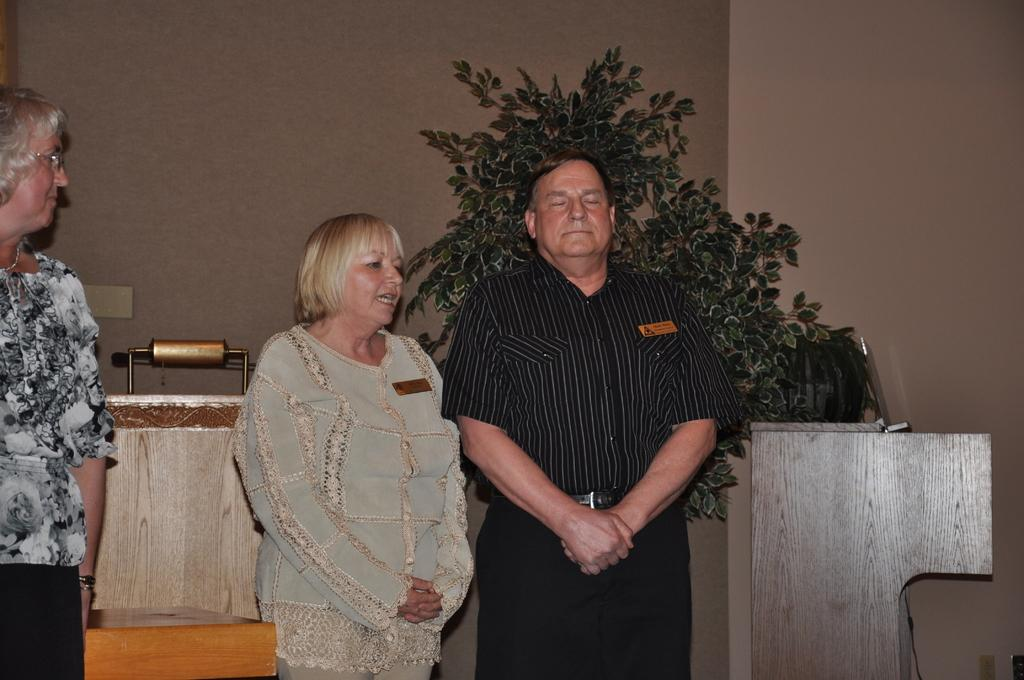How many people are in the image? There are three persons standing in the image. What can be seen on the wall in the background of the image? There is a board on the wall in the background of the image. What type of vegetation is visible in the background of the image? There are plants in the background of the image. What type of material is used for the objects in the background of the image? There are wooden objects in the background of the image. Can you describe the other objects visible in the background of the image? There are other objects visible in the background of the image, but their specific details are not mentioned in the provided facts. What type of music is being played in the cellar in the image? There is no mention of a cellar or music in the image, so it cannot be determined from the provided facts. 